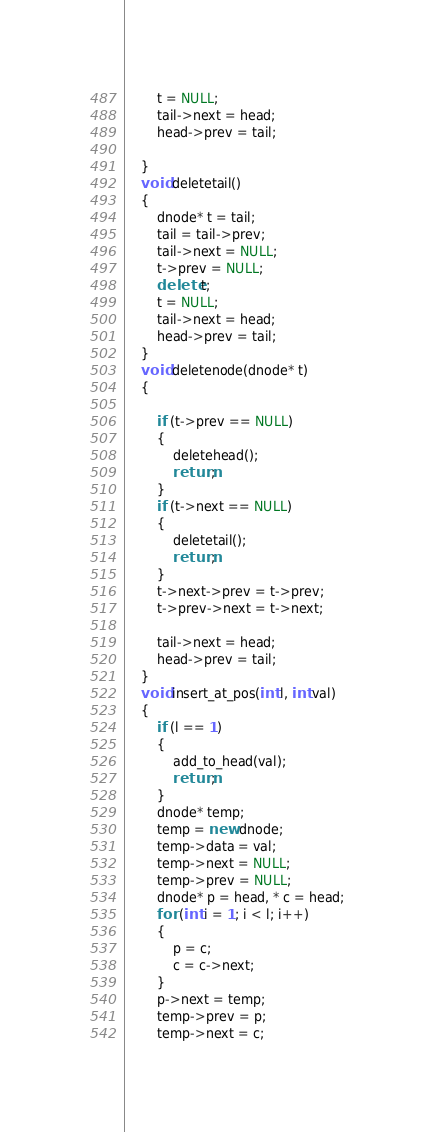<code> <loc_0><loc_0><loc_500><loc_500><_C++_>        t = NULL;
        tail->next = head;
        head->prev = tail;

    }
    void deletetail()
    {
        dnode* t = tail;
        tail = tail->prev;
        tail->next = NULL;
        t->prev = NULL;
        delete t;
        t = NULL;
        tail->next = head;
        head->prev = tail;
    }
    void deletenode(dnode* t)
    {

        if (t->prev == NULL)
        {
            deletehead();
            return;
        }
        if (t->next == NULL)
        {
            deletetail();
            return;
        }
        t->next->prev = t->prev;
        t->prev->next = t->next;

        tail->next = head;
        head->prev = tail;
    }
    void insert_at_pos(int l, int val)
    {
        if (l == 1)
        {
            add_to_head(val);
            return;
        }
        dnode* temp;
        temp = new dnode;
        temp->data = val;
        temp->next = NULL;
        temp->prev = NULL;
        dnode* p = head, * c = head;
        for (int i = 1; i < l; i++)
        {
            p = c;
            c = c->next;
        }
        p->next = temp;
        temp->prev = p;
        temp->next = c;</code> 